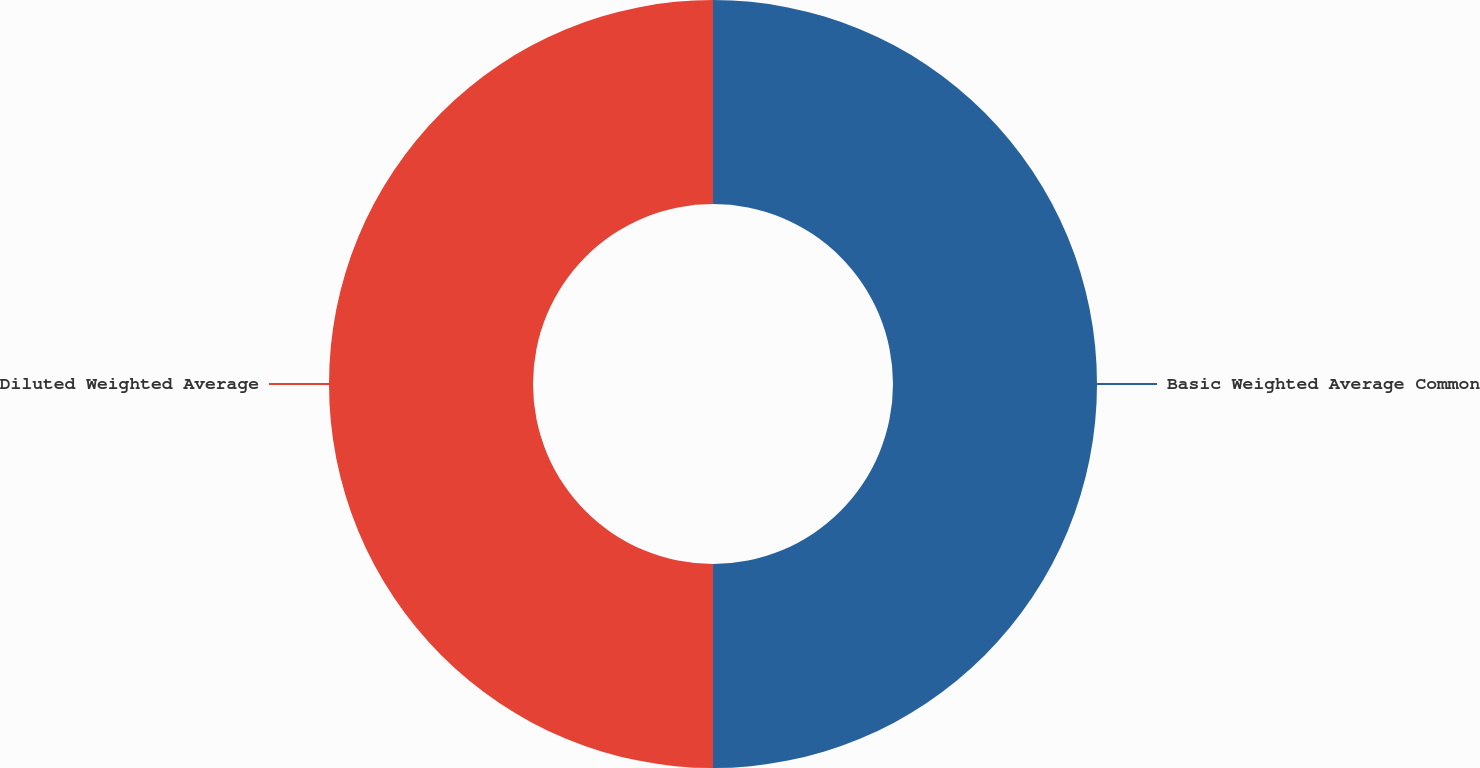Convert chart to OTSL. <chart><loc_0><loc_0><loc_500><loc_500><pie_chart><fcel>Basic Weighted Average Common<fcel>Diluted Weighted Average<nl><fcel>50.0%<fcel>50.0%<nl></chart> 